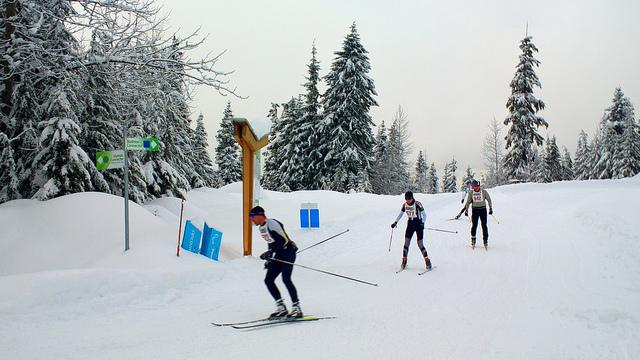Where was modern skiing invented? Please explain your reasoning. scandinavia. It was first done in scandinavia. 